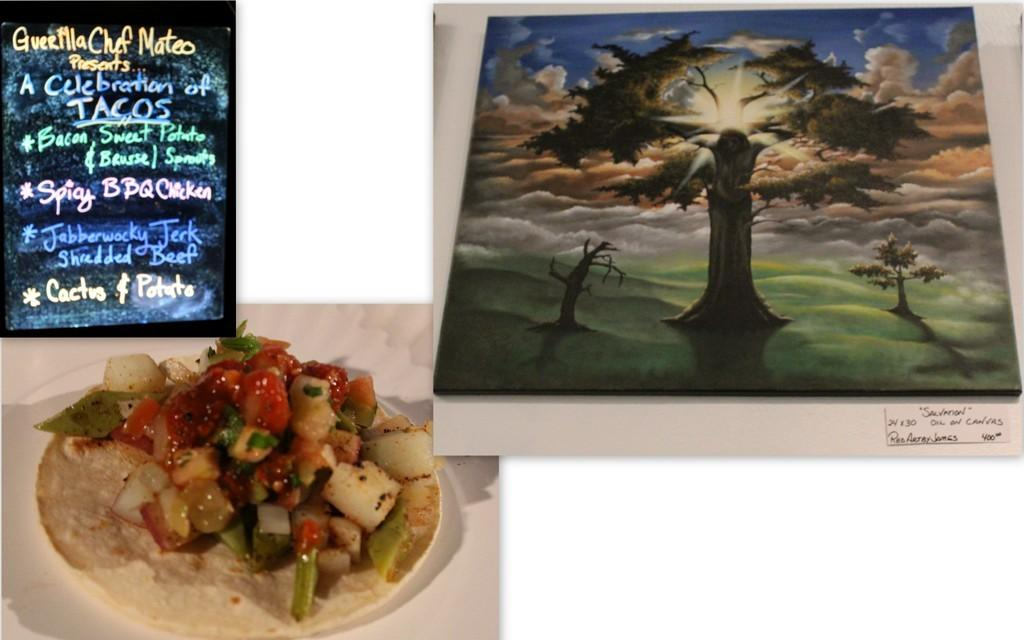What can be observed about the image's appearance? The image appears to be edited. What is on the plate in the image? There is a food item on a plate. What is written on the board in the image? There is a board with text in the image. What type of natural environment is visible in the image? Trees and the sky are visible in the image. What channel is the bird watching on the plate in the image? There is no bird or television channel present in the image. 